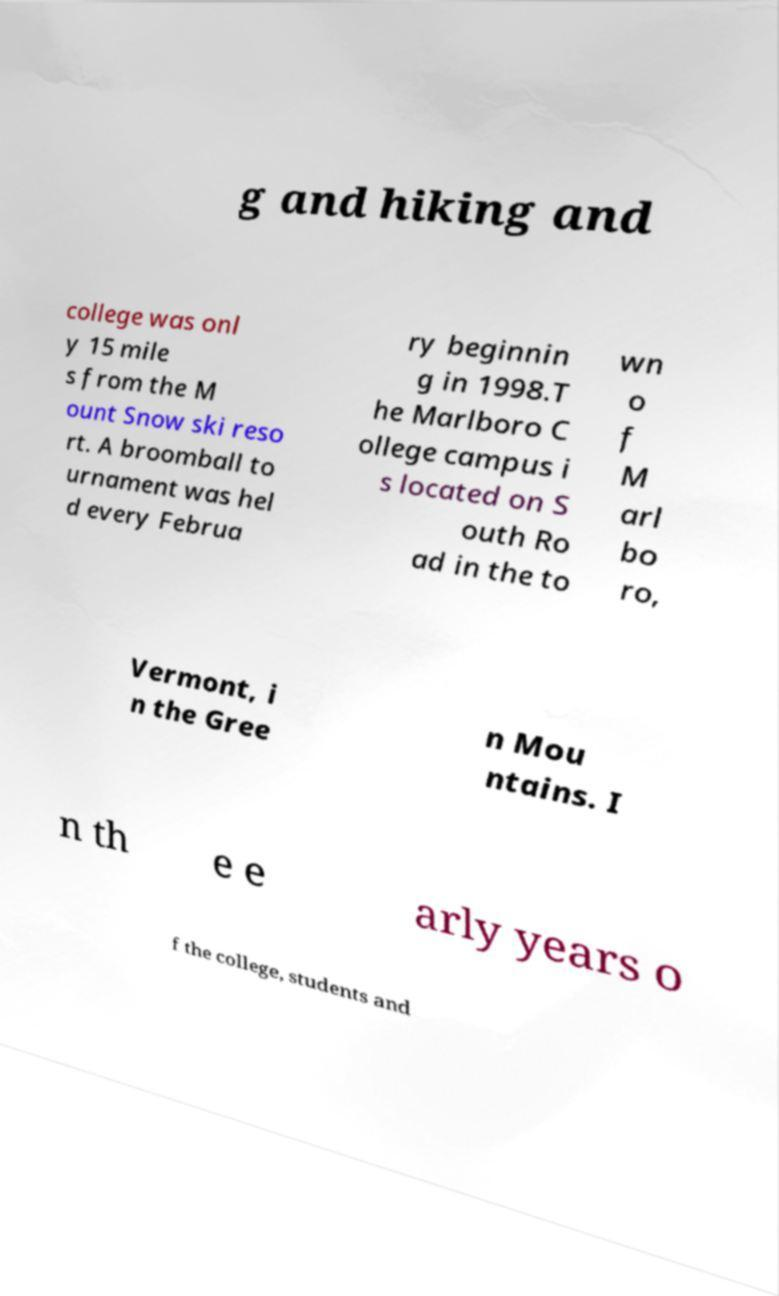Please read and relay the text visible in this image. What does it say? g and hiking and college was onl y 15 mile s from the M ount Snow ski reso rt. A broomball to urnament was hel d every Februa ry beginnin g in 1998.T he Marlboro C ollege campus i s located on S outh Ro ad in the to wn o f M arl bo ro, Vermont, i n the Gree n Mou ntains. I n th e e arly years o f the college, students and 